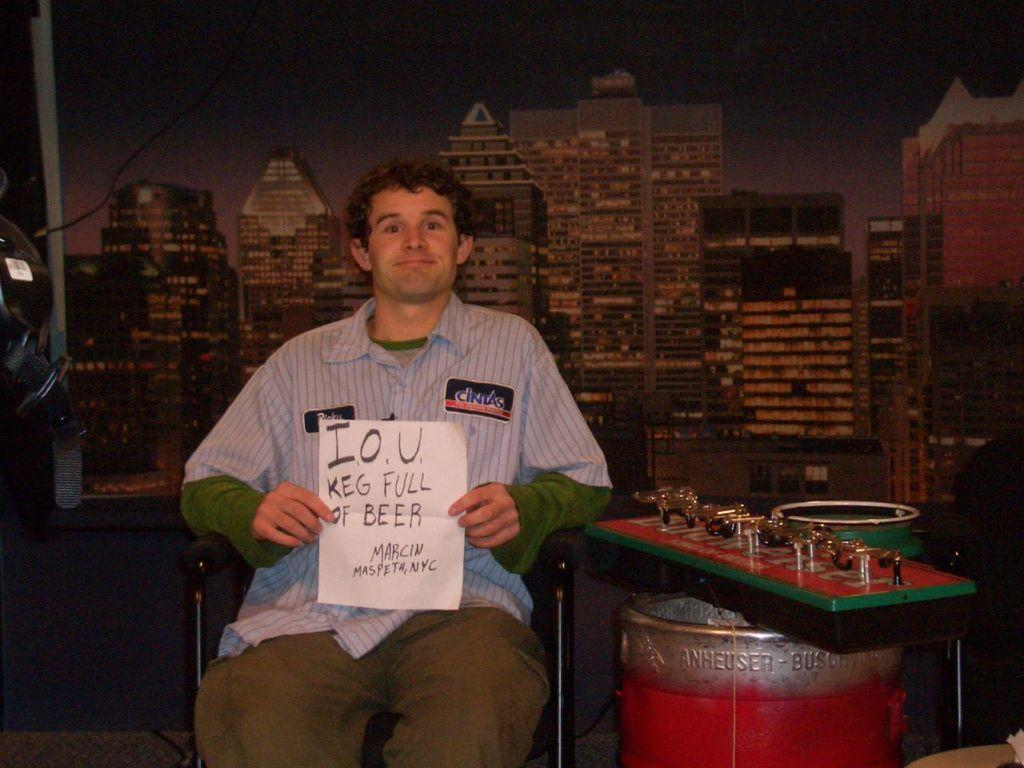What is the person in the image doing? The person is sitting on a chair in the image. What is the person holding in the image? The person is holding a paper. What musical instrument can be seen in the image? There is a musical instrument in the image. What other object related to music can be seen in the image? There is a drum in the image. What is visible at the top of the image? There is a building and the sky visible at the top of the image. What type of cabbage is being used as a hat in the image? There is no cabbage present in the image, let alone being used as a hat. 